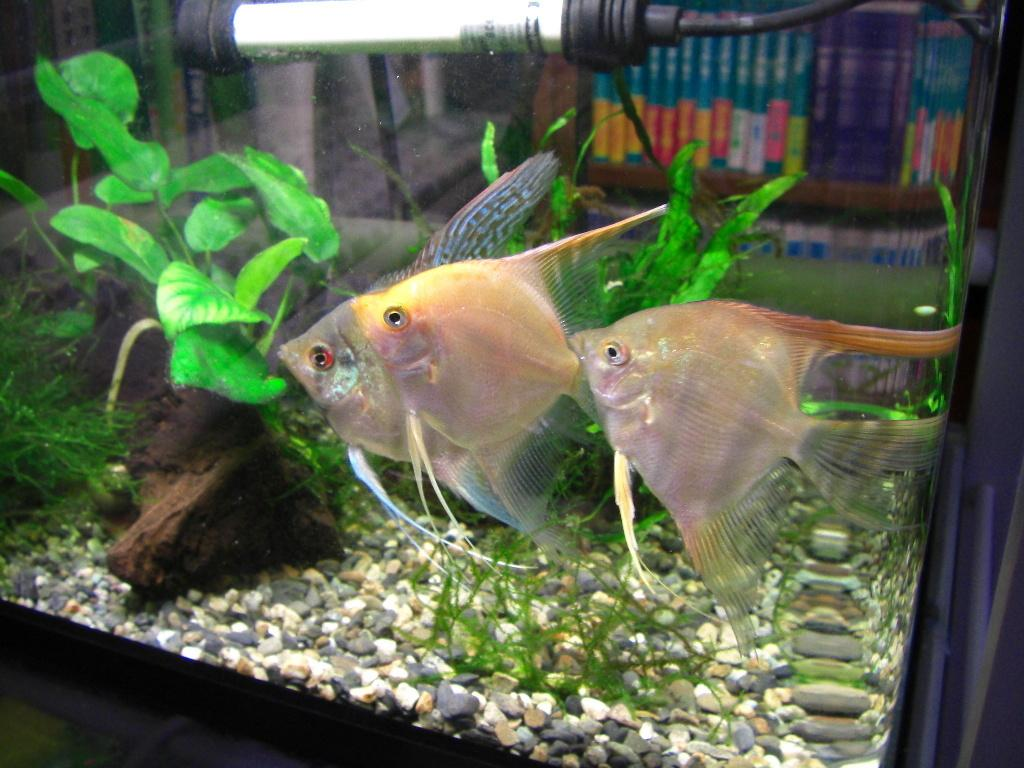How many fishes can be seen in the aquarium in the image? There are three fishes in the aquarium in the image. What are the fishes doing in the image? The fishes are swimming in the image. What can be seen in the background of the image? There are trees, stones, and lights in the background of the image. What type of stem can be seen growing from the fishes in the image? There are no stems growing from the fishes in the image; they are swimming in an aquarium. 